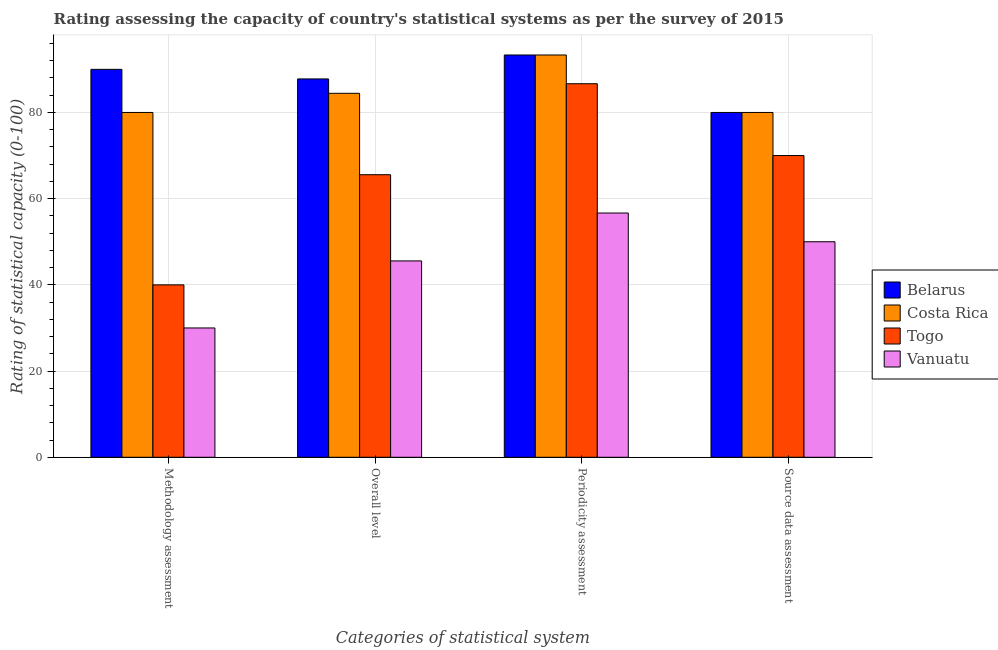How many groups of bars are there?
Offer a very short reply. 4. Are the number of bars per tick equal to the number of legend labels?
Your response must be concise. Yes. How many bars are there on the 1st tick from the left?
Give a very brief answer. 4. How many bars are there on the 2nd tick from the right?
Keep it short and to the point. 4. What is the label of the 4th group of bars from the left?
Keep it short and to the point. Source data assessment. Across all countries, what is the minimum overall level rating?
Make the answer very short. 45.56. In which country was the periodicity assessment rating maximum?
Your response must be concise. Belarus. In which country was the overall level rating minimum?
Your answer should be compact. Vanuatu. What is the total overall level rating in the graph?
Your response must be concise. 283.33. What is the difference between the overall level rating in Belarus and that in Costa Rica?
Make the answer very short. 3.33. What is the difference between the overall level rating in Belarus and the methodology assessment rating in Togo?
Your answer should be very brief. 47.78. What is the average overall level rating per country?
Offer a terse response. 70.83. What is the difference between the source data assessment rating and methodology assessment rating in Belarus?
Your answer should be very brief. -10. In how many countries, is the methodology assessment rating greater than 24 ?
Your answer should be very brief. 4. What is the ratio of the periodicity assessment rating in Vanuatu to that in Costa Rica?
Ensure brevity in your answer.  0.61. In how many countries, is the overall level rating greater than the average overall level rating taken over all countries?
Offer a terse response. 2. Is it the case that in every country, the sum of the periodicity assessment rating and source data assessment rating is greater than the sum of overall level rating and methodology assessment rating?
Give a very brief answer. No. What does the 1st bar from the left in Overall level represents?
Offer a terse response. Belarus. What does the 3rd bar from the right in Periodicity assessment represents?
Keep it short and to the point. Costa Rica. Is it the case that in every country, the sum of the methodology assessment rating and overall level rating is greater than the periodicity assessment rating?
Offer a terse response. Yes. How many bars are there?
Ensure brevity in your answer.  16. Are all the bars in the graph horizontal?
Provide a short and direct response. No. How many countries are there in the graph?
Provide a short and direct response. 4. Where does the legend appear in the graph?
Your answer should be very brief. Center right. How many legend labels are there?
Your answer should be very brief. 4. How are the legend labels stacked?
Provide a succinct answer. Vertical. What is the title of the graph?
Offer a very short reply. Rating assessing the capacity of country's statistical systems as per the survey of 2015 . Does "Brazil" appear as one of the legend labels in the graph?
Make the answer very short. No. What is the label or title of the X-axis?
Your response must be concise. Categories of statistical system. What is the label or title of the Y-axis?
Ensure brevity in your answer.  Rating of statistical capacity (0-100). What is the Rating of statistical capacity (0-100) in Belarus in Methodology assessment?
Ensure brevity in your answer.  90. What is the Rating of statistical capacity (0-100) in Costa Rica in Methodology assessment?
Ensure brevity in your answer.  80. What is the Rating of statistical capacity (0-100) of Togo in Methodology assessment?
Your answer should be compact. 40. What is the Rating of statistical capacity (0-100) in Vanuatu in Methodology assessment?
Provide a short and direct response. 30. What is the Rating of statistical capacity (0-100) in Belarus in Overall level?
Keep it short and to the point. 87.78. What is the Rating of statistical capacity (0-100) in Costa Rica in Overall level?
Your response must be concise. 84.44. What is the Rating of statistical capacity (0-100) in Togo in Overall level?
Ensure brevity in your answer.  65.56. What is the Rating of statistical capacity (0-100) in Vanuatu in Overall level?
Offer a terse response. 45.56. What is the Rating of statistical capacity (0-100) of Belarus in Periodicity assessment?
Ensure brevity in your answer.  93.33. What is the Rating of statistical capacity (0-100) of Costa Rica in Periodicity assessment?
Ensure brevity in your answer.  93.33. What is the Rating of statistical capacity (0-100) in Togo in Periodicity assessment?
Your response must be concise. 86.67. What is the Rating of statistical capacity (0-100) in Vanuatu in Periodicity assessment?
Ensure brevity in your answer.  56.67. What is the Rating of statistical capacity (0-100) in Costa Rica in Source data assessment?
Your response must be concise. 80. What is the Rating of statistical capacity (0-100) of Vanuatu in Source data assessment?
Make the answer very short. 50. Across all Categories of statistical system, what is the maximum Rating of statistical capacity (0-100) in Belarus?
Your response must be concise. 93.33. Across all Categories of statistical system, what is the maximum Rating of statistical capacity (0-100) in Costa Rica?
Ensure brevity in your answer.  93.33. Across all Categories of statistical system, what is the maximum Rating of statistical capacity (0-100) of Togo?
Make the answer very short. 86.67. Across all Categories of statistical system, what is the maximum Rating of statistical capacity (0-100) in Vanuatu?
Make the answer very short. 56.67. Across all Categories of statistical system, what is the minimum Rating of statistical capacity (0-100) in Togo?
Provide a succinct answer. 40. What is the total Rating of statistical capacity (0-100) in Belarus in the graph?
Ensure brevity in your answer.  351.11. What is the total Rating of statistical capacity (0-100) of Costa Rica in the graph?
Give a very brief answer. 337.78. What is the total Rating of statistical capacity (0-100) in Togo in the graph?
Give a very brief answer. 262.22. What is the total Rating of statistical capacity (0-100) of Vanuatu in the graph?
Ensure brevity in your answer.  182.22. What is the difference between the Rating of statistical capacity (0-100) in Belarus in Methodology assessment and that in Overall level?
Ensure brevity in your answer.  2.22. What is the difference between the Rating of statistical capacity (0-100) in Costa Rica in Methodology assessment and that in Overall level?
Offer a very short reply. -4.44. What is the difference between the Rating of statistical capacity (0-100) of Togo in Methodology assessment and that in Overall level?
Ensure brevity in your answer.  -25.56. What is the difference between the Rating of statistical capacity (0-100) of Vanuatu in Methodology assessment and that in Overall level?
Make the answer very short. -15.56. What is the difference between the Rating of statistical capacity (0-100) in Costa Rica in Methodology assessment and that in Periodicity assessment?
Make the answer very short. -13.33. What is the difference between the Rating of statistical capacity (0-100) in Togo in Methodology assessment and that in Periodicity assessment?
Offer a terse response. -46.67. What is the difference between the Rating of statistical capacity (0-100) of Vanuatu in Methodology assessment and that in Periodicity assessment?
Your response must be concise. -26.67. What is the difference between the Rating of statistical capacity (0-100) in Belarus in Methodology assessment and that in Source data assessment?
Provide a succinct answer. 10. What is the difference between the Rating of statistical capacity (0-100) of Costa Rica in Methodology assessment and that in Source data assessment?
Offer a terse response. 0. What is the difference between the Rating of statistical capacity (0-100) in Belarus in Overall level and that in Periodicity assessment?
Offer a terse response. -5.56. What is the difference between the Rating of statistical capacity (0-100) of Costa Rica in Overall level and that in Periodicity assessment?
Make the answer very short. -8.89. What is the difference between the Rating of statistical capacity (0-100) in Togo in Overall level and that in Periodicity assessment?
Your answer should be compact. -21.11. What is the difference between the Rating of statistical capacity (0-100) of Vanuatu in Overall level and that in Periodicity assessment?
Your answer should be compact. -11.11. What is the difference between the Rating of statistical capacity (0-100) in Belarus in Overall level and that in Source data assessment?
Your answer should be very brief. 7.78. What is the difference between the Rating of statistical capacity (0-100) of Costa Rica in Overall level and that in Source data assessment?
Keep it short and to the point. 4.44. What is the difference between the Rating of statistical capacity (0-100) of Togo in Overall level and that in Source data assessment?
Keep it short and to the point. -4.44. What is the difference between the Rating of statistical capacity (0-100) in Vanuatu in Overall level and that in Source data assessment?
Your answer should be very brief. -4.44. What is the difference between the Rating of statistical capacity (0-100) of Belarus in Periodicity assessment and that in Source data assessment?
Provide a short and direct response. 13.33. What is the difference between the Rating of statistical capacity (0-100) of Costa Rica in Periodicity assessment and that in Source data assessment?
Make the answer very short. 13.33. What is the difference between the Rating of statistical capacity (0-100) of Togo in Periodicity assessment and that in Source data assessment?
Keep it short and to the point. 16.67. What is the difference between the Rating of statistical capacity (0-100) of Vanuatu in Periodicity assessment and that in Source data assessment?
Offer a terse response. 6.67. What is the difference between the Rating of statistical capacity (0-100) in Belarus in Methodology assessment and the Rating of statistical capacity (0-100) in Costa Rica in Overall level?
Provide a succinct answer. 5.56. What is the difference between the Rating of statistical capacity (0-100) of Belarus in Methodology assessment and the Rating of statistical capacity (0-100) of Togo in Overall level?
Give a very brief answer. 24.44. What is the difference between the Rating of statistical capacity (0-100) in Belarus in Methodology assessment and the Rating of statistical capacity (0-100) in Vanuatu in Overall level?
Provide a short and direct response. 44.44. What is the difference between the Rating of statistical capacity (0-100) in Costa Rica in Methodology assessment and the Rating of statistical capacity (0-100) in Togo in Overall level?
Your answer should be compact. 14.44. What is the difference between the Rating of statistical capacity (0-100) in Costa Rica in Methodology assessment and the Rating of statistical capacity (0-100) in Vanuatu in Overall level?
Give a very brief answer. 34.44. What is the difference between the Rating of statistical capacity (0-100) in Togo in Methodology assessment and the Rating of statistical capacity (0-100) in Vanuatu in Overall level?
Provide a short and direct response. -5.56. What is the difference between the Rating of statistical capacity (0-100) of Belarus in Methodology assessment and the Rating of statistical capacity (0-100) of Vanuatu in Periodicity assessment?
Your answer should be compact. 33.33. What is the difference between the Rating of statistical capacity (0-100) of Costa Rica in Methodology assessment and the Rating of statistical capacity (0-100) of Togo in Periodicity assessment?
Offer a terse response. -6.67. What is the difference between the Rating of statistical capacity (0-100) of Costa Rica in Methodology assessment and the Rating of statistical capacity (0-100) of Vanuatu in Periodicity assessment?
Make the answer very short. 23.33. What is the difference between the Rating of statistical capacity (0-100) in Togo in Methodology assessment and the Rating of statistical capacity (0-100) in Vanuatu in Periodicity assessment?
Keep it short and to the point. -16.67. What is the difference between the Rating of statistical capacity (0-100) of Belarus in Methodology assessment and the Rating of statistical capacity (0-100) of Vanuatu in Source data assessment?
Give a very brief answer. 40. What is the difference between the Rating of statistical capacity (0-100) of Costa Rica in Methodology assessment and the Rating of statistical capacity (0-100) of Togo in Source data assessment?
Provide a succinct answer. 10. What is the difference between the Rating of statistical capacity (0-100) in Costa Rica in Methodology assessment and the Rating of statistical capacity (0-100) in Vanuatu in Source data assessment?
Offer a terse response. 30. What is the difference between the Rating of statistical capacity (0-100) of Togo in Methodology assessment and the Rating of statistical capacity (0-100) of Vanuatu in Source data assessment?
Give a very brief answer. -10. What is the difference between the Rating of statistical capacity (0-100) in Belarus in Overall level and the Rating of statistical capacity (0-100) in Costa Rica in Periodicity assessment?
Give a very brief answer. -5.56. What is the difference between the Rating of statistical capacity (0-100) of Belarus in Overall level and the Rating of statistical capacity (0-100) of Vanuatu in Periodicity assessment?
Ensure brevity in your answer.  31.11. What is the difference between the Rating of statistical capacity (0-100) of Costa Rica in Overall level and the Rating of statistical capacity (0-100) of Togo in Periodicity assessment?
Your answer should be compact. -2.22. What is the difference between the Rating of statistical capacity (0-100) of Costa Rica in Overall level and the Rating of statistical capacity (0-100) of Vanuatu in Periodicity assessment?
Your response must be concise. 27.78. What is the difference between the Rating of statistical capacity (0-100) of Togo in Overall level and the Rating of statistical capacity (0-100) of Vanuatu in Periodicity assessment?
Offer a terse response. 8.89. What is the difference between the Rating of statistical capacity (0-100) of Belarus in Overall level and the Rating of statistical capacity (0-100) of Costa Rica in Source data assessment?
Your answer should be compact. 7.78. What is the difference between the Rating of statistical capacity (0-100) in Belarus in Overall level and the Rating of statistical capacity (0-100) in Togo in Source data assessment?
Offer a terse response. 17.78. What is the difference between the Rating of statistical capacity (0-100) of Belarus in Overall level and the Rating of statistical capacity (0-100) of Vanuatu in Source data assessment?
Offer a terse response. 37.78. What is the difference between the Rating of statistical capacity (0-100) of Costa Rica in Overall level and the Rating of statistical capacity (0-100) of Togo in Source data assessment?
Your answer should be very brief. 14.44. What is the difference between the Rating of statistical capacity (0-100) in Costa Rica in Overall level and the Rating of statistical capacity (0-100) in Vanuatu in Source data assessment?
Your response must be concise. 34.44. What is the difference between the Rating of statistical capacity (0-100) of Togo in Overall level and the Rating of statistical capacity (0-100) of Vanuatu in Source data assessment?
Give a very brief answer. 15.56. What is the difference between the Rating of statistical capacity (0-100) of Belarus in Periodicity assessment and the Rating of statistical capacity (0-100) of Costa Rica in Source data assessment?
Offer a terse response. 13.33. What is the difference between the Rating of statistical capacity (0-100) of Belarus in Periodicity assessment and the Rating of statistical capacity (0-100) of Togo in Source data assessment?
Provide a succinct answer. 23.33. What is the difference between the Rating of statistical capacity (0-100) in Belarus in Periodicity assessment and the Rating of statistical capacity (0-100) in Vanuatu in Source data assessment?
Make the answer very short. 43.33. What is the difference between the Rating of statistical capacity (0-100) in Costa Rica in Periodicity assessment and the Rating of statistical capacity (0-100) in Togo in Source data assessment?
Make the answer very short. 23.33. What is the difference between the Rating of statistical capacity (0-100) in Costa Rica in Periodicity assessment and the Rating of statistical capacity (0-100) in Vanuatu in Source data assessment?
Your answer should be compact. 43.33. What is the difference between the Rating of statistical capacity (0-100) of Togo in Periodicity assessment and the Rating of statistical capacity (0-100) of Vanuatu in Source data assessment?
Make the answer very short. 36.67. What is the average Rating of statistical capacity (0-100) of Belarus per Categories of statistical system?
Offer a terse response. 87.78. What is the average Rating of statistical capacity (0-100) in Costa Rica per Categories of statistical system?
Provide a short and direct response. 84.44. What is the average Rating of statistical capacity (0-100) in Togo per Categories of statistical system?
Keep it short and to the point. 65.56. What is the average Rating of statistical capacity (0-100) of Vanuatu per Categories of statistical system?
Provide a succinct answer. 45.56. What is the difference between the Rating of statistical capacity (0-100) of Belarus and Rating of statistical capacity (0-100) of Togo in Methodology assessment?
Your answer should be very brief. 50. What is the difference between the Rating of statistical capacity (0-100) of Costa Rica and Rating of statistical capacity (0-100) of Togo in Methodology assessment?
Offer a terse response. 40. What is the difference between the Rating of statistical capacity (0-100) in Costa Rica and Rating of statistical capacity (0-100) in Vanuatu in Methodology assessment?
Your answer should be very brief. 50. What is the difference between the Rating of statistical capacity (0-100) in Togo and Rating of statistical capacity (0-100) in Vanuatu in Methodology assessment?
Your answer should be very brief. 10. What is the difference between the Rating of statistical capacity (0-100) in Belarus and Rating of statistical capacity (0-100) in Costa Rica in Overall level?
Your response must be concise. 3.33. What is the difference between the Rating of statistical capacity (0-100) of Belarus and Rating of statistical capacity (0-100) of Togo in Overall level?
Your response must be concise. 22.22. What is the difference between the Rating of statistical capacity (0-100) of Belarus and Rating of statistical capacity (0-100) of Vanuatu in Overall level?
Your answer should be very brief. 42.22. What is the difference between the Rating of statistical capacity (0-100) in Costa Rica and Rating of statistical capacity (0-100) in Togo in Overall level?
Ensure brevity in your answer.  18.89. What is the difference between the Rating of statistical capacity (0-100) of Costa Rica and Rating of statistical capacity (0-100) of Vanuatu in Overall level?
Offer a terse response. 38.89. What is the difference between the Rating of statistical capacity (0-100) of Belarus and Rating of statistical capacity (0-100) of Costa Rica in Periodicity assessment?
Provide a short and direct response. 0. What is the difference between the Rating of statistical capacity (0-100) of Belarus and Rating of statistical capacity (0-100) of Togo in Periodicity assessment?
Ensure brevity in your answer.  6.67. What is the difference between the Rating of statistical capacity (0-100) of Belarus and Rating of statistical capacity (0-100) of Vanuatu in Periodicity assessment?
Offer a terse response. 36.67. What is the difference between the Rating of statistical capacity (0-100) in Costa Rica and Rating of statistical capacity (0-100) in Togo in Periodicity assessment?
Keep it short and to the point. 6.67. What is the difference between the Rating of statistical capacity (0-100) of Costa Rica and Rating of statistical capacity (0-100) of Vanuatu in Periodicity assessment?
Give a very brief answer. 36.67. What is the difference between the Rating of statistical capacity (0-100) of Belarus and Rating of statistical capacity (0-100) of Vanuatu in Source data assessment?
Your answer should be very brief. 30. What is the ratio of the Rating of statistical capacity (0-100) in Belarus in Methodology assessment to that in Overall level?
Provide a short and direct response. 1.03. What is the ratio of the Rating of statistical capacity (0-100) of Costa Rica in Methodology assessment to that in Overall level?
Ensure brevity in your answer.  0.95. What is the ratio of the Rating of statistical capacity (0-100) of Togo in Methodology assessment to that in Overall level?
Your response must be concise. 0.61. What is the ratio of the Rating of statistical capacity (0-100) in Vanuatu in Methodology assessment to that in Overall level?
Your response must be concise. 0.66. What is the ratio of the Rating of statistical capacity (0-100) of Belarus in Methodology assessment to that in Periodicity assessment?
Offer a terse response. 0.96. What is the ratio of the Rating of statistical capacity (0-100) in Costa Rica in Methodology assessment to that in Periodicity assessment?
Your response must be concise. 0.86. What is the ratio of the Rating of statistical capacity (0-100) in Togo in Methodology assessment to that in Periodicity assessment?
Offer a very short reply. 0.46. What is the ratio of the Rating of statistical capacity (0-100) of Vanuatu in Methodology assessment to that in Periodicity assessment?
Keep it short and to the point. 0.53. What is the ratio of the Rating of statistical capacity (0-100) in Togo in Methodology assessment to that in Source data assessment?
Your answer should be very brief. 0.57. What is the ratio of the Rating of statistical capacity (0-100) of Vanuatu in Methodology assessment to that in Source data assessment?
Provide a succinct answer. 0.6. What is the ratio of the Rating of statistical capacity (0-100) in Belarus in Overall level to that in Periodicity assessment?
Ensure brevity in your answer.  0.94. What is the ratio of the Rating of statistical capacity (0-100) of Costa Rica in Overall level to that in Periodicity assessment?
Ensure brevity in your answer.  0.9. What is the ratio of the Rating of statistical capacity (0-100) in Togo in Overall level to that in Periodicity assessment?
Give a very brief answer. 0.76. What is the ratio of the Rating of statistical capacity (0-100) in Vanuatu in Overall level to that in Periodicity assessment?
Make the answer very short. 0.8. What is the ratio of the Rating of statistical capacity (0-100) in Belarus in Overall level to that in Source data assessment?
Offer a terse response. 1.1. What is the ratio of the Rating of statistical capacity (0-100) of Costa Rica in Overall level to that in Source data assessment?
Provide a short and direct response. 1.06. What is the ratio of the Rating of statistical capacity (0-100) of Togo in Overall level to that in Source data assessment?
Your answer should be compact. 0.94. What is the ratio of the Rating of statistical capacity (0-100) in Vanuatu in Overall level to that in Source data assessment?
Give a very brief answer. 0.91. What is the ratio of the Rating of statistical capacity (0-100) of Belarus in Periodicity assessment to that in Source data assessment?
Offer a very short reply. 1.17. What is the ratio of the Rating of statistical capacity (0-100) in Costa Rica in Periodicity assessment to that in Source data assessment?
Your response must be concise. 1.17. What is the ratio of the Rating of statistical capacity (0-100) of Togo in Periodicity assessment to that in Source data assessment?
Offer a terse response. 1.24. What is the ratio of the Rating of statistical capacity (0-100) of Vanuatu in Periodicity assessment to that in Source data assessment?
Offer a very short reply. 1.13. What is the difference between the highest and the second highest Rating of statistical capacity (0-100) of Costa Rica?
Give a very brief answer. 8.89. What is the difference between the highest and the second highest Rating of statistical capacity (0-100) of Togo?
Your answer should be very brief. 16.67. What is the difference between the highest and the lowest Rating of statistical capacity (0-100) of Belarus?
Offer a terse response. 13.33. What is the difference between the highest and the lowest Rating of statistical capacity (0-100) in Costa Rica?
Provide a succinct answer. 13.33. What is the difference between the highest and the lowest Rating of statistical capacity (0-100) of Togo?
Offer a very short reply. 46.67. What is the difference between the highest and the lowest Rating of statistical capacity (0-100) in Vanuatu?
Offer a terse response. 26.67. 